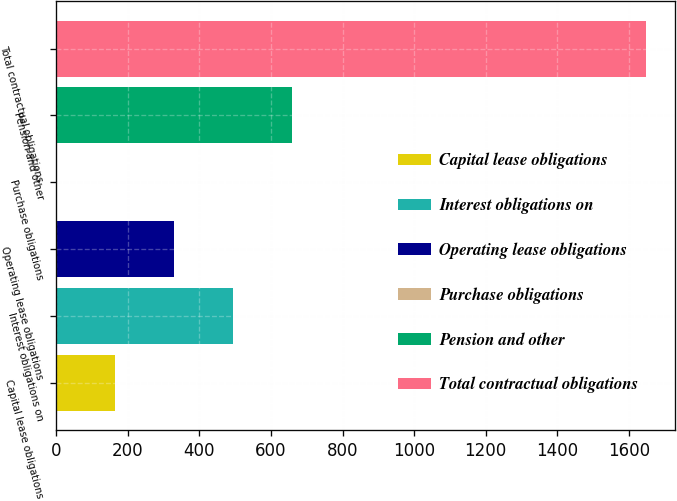<chart> <loc_0><loc_0><loc_500><loc_500><bar_chart><fcel>Capital lease obligations<fcel>Interest obligations on<fcel>Operating lease obligations<fcel>Purchase obligations<fcel>Pension and other<fcel>Total contractual obligations<nl><fcel>164.91<fcel>494.33<fcel>329.62<fcel>0.2<fcel>659.04<fcel>1647.3<nl></chart> 